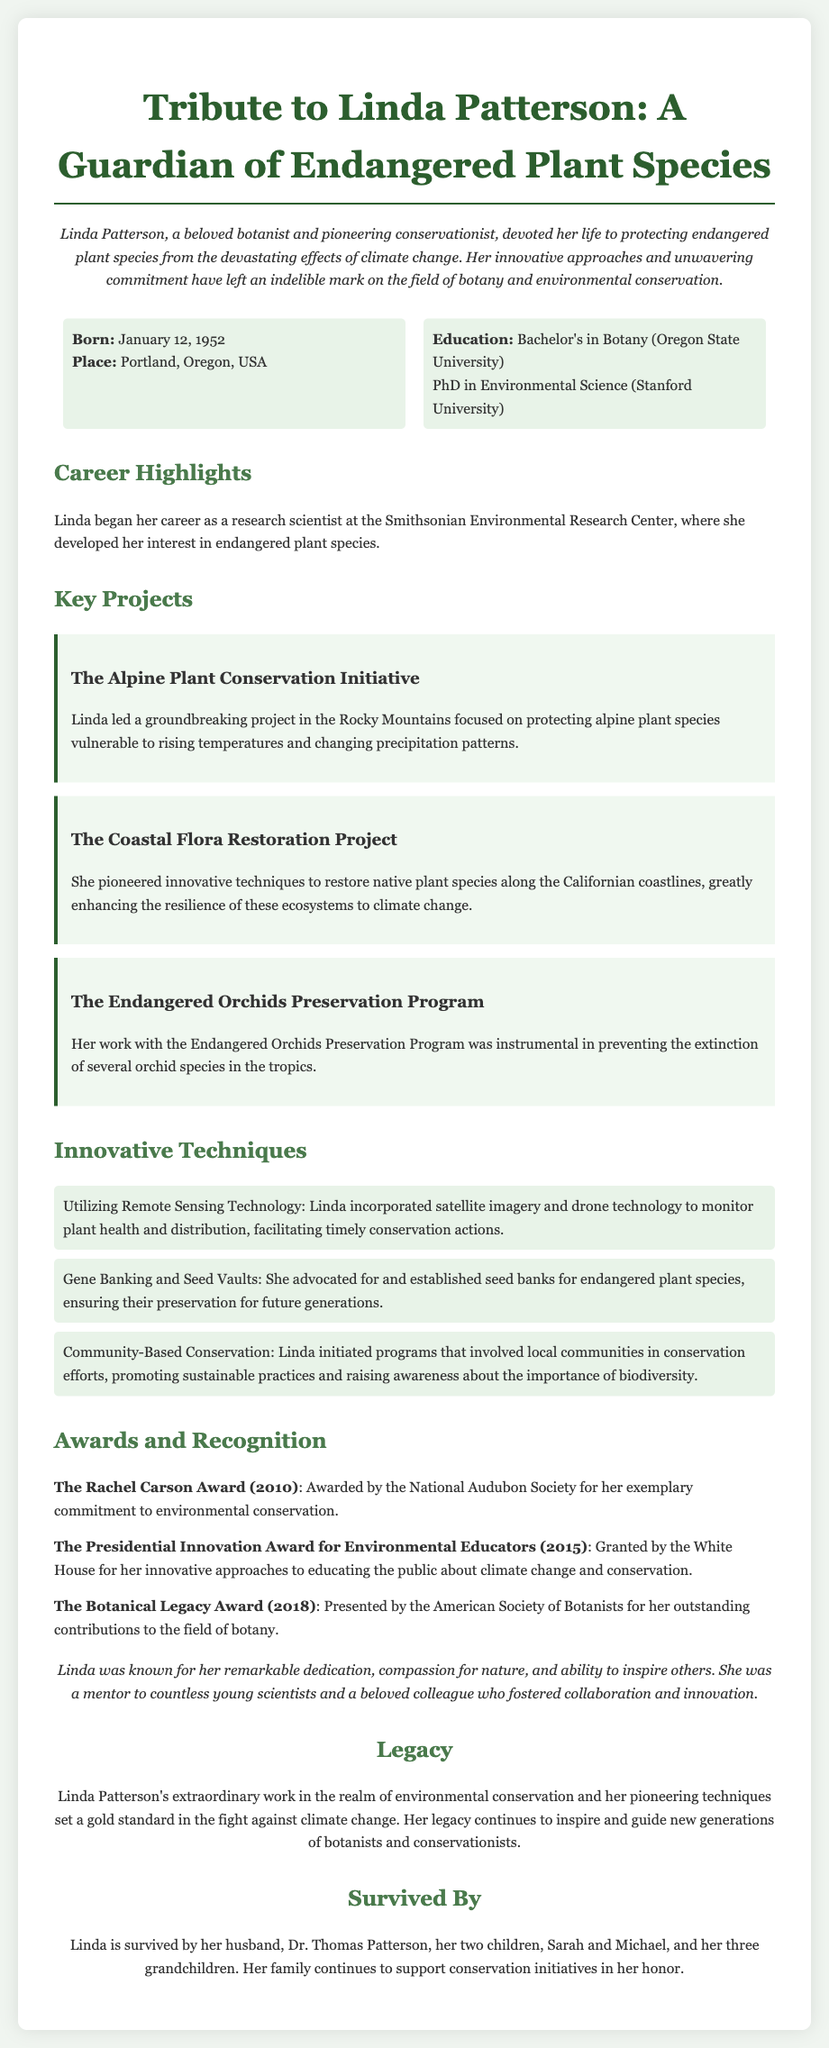what was Linda Patterson's role in conservation? The document describes Linda Patterson as a pioneering conservationist dedicated to protecting endangered plant species.
Answer: pioneering conservationist when was Linda Patterson born? The document states that Linda Patterson was born on January 12, 1952.
Answer: January 12, 1952 where did Linda Patterson earn her Bachelor's degree? The document mentions that she earned her Bachelor's in Botany from Oregon State University.
Answer: Oregon State University what was one of the innovative techniques used by Linda Patterson? The document lists several techniques, including utilizing remote sensing technology.
Answer: utilizing remote sensing technology which award did Linda receive in 2010? According to the document, Linda received The Rachel Carson Award in 2010.
Answer: The Rachel Carson Award which project focused on alpine species? The document refers to The Alpine Plant Conservation Initiative as the project focusing on alpine species.
Answer: The Alpine Plant Conservation Initiative what did Linda's family continue to support after her death? The document states that her family continues to support conservation initiatives in her honor.
Answer: conservation initiatives how many children did Linda have? The document states that Linda had two children.
Answer: two children what was Linda's highest educational qualification? The document indicates that she earned a PhD in Environmental Science from Stanford University.
Answer: PhD in Environmental Science 